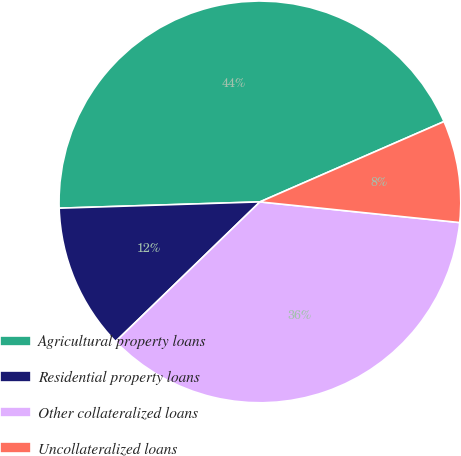<chart> <loc_0><loc_0><loc_500><loc_500><pie_chart><fcel>Agricultural property loans<fcel>Residential property loans<fcel>Other collateralized loans<fcel>Uncollateralized loans<nl><fcel>43.95%<fcel>11.74%<fcel>36.12%<fcel>8.19%<nl></chart> 